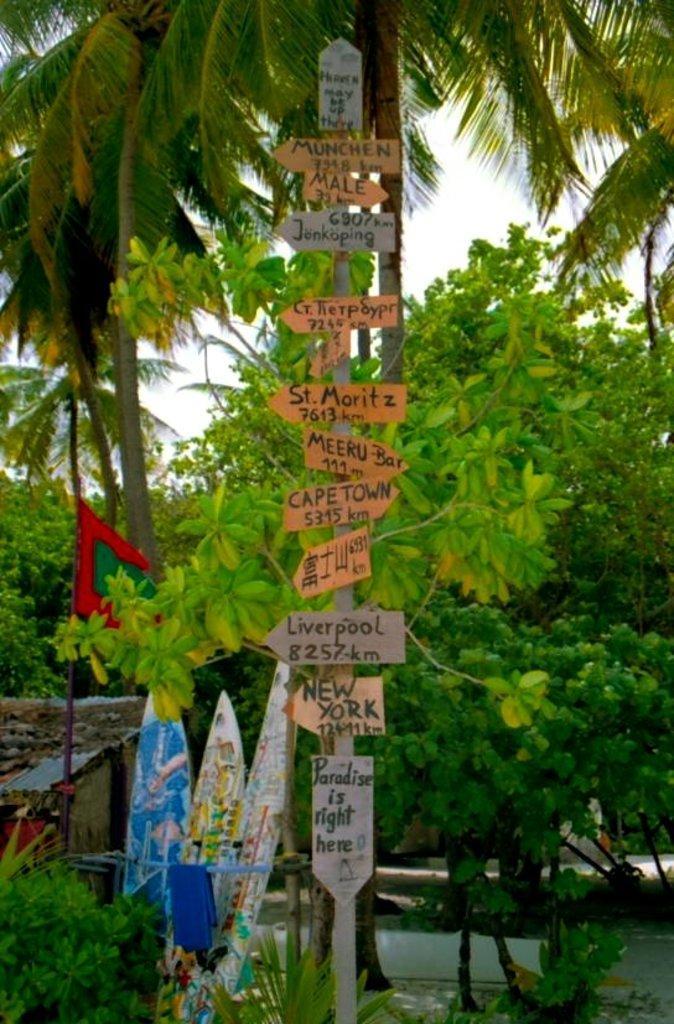How would you summarize this image in a sentence or two? In front of the image there are sign boards on a pole, behind the sign boards, there are surfing boards, plants, trees and a house. 